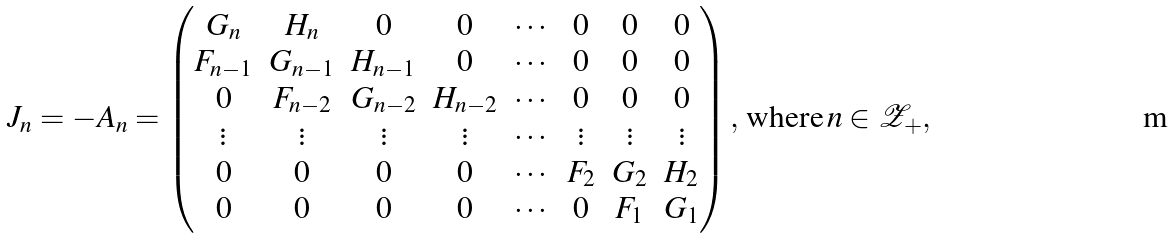Convert formula to latex. <formula><loc_0><loc_0><loc_500><loc_500>J _ { n } = - A _ { n } = \begin{pmatrix} G _ { n } & H _ { n } & 0 & 0 & \cdots & 0 & 0 & 0 \\ F _ { n - 1 } & G _ { n - 1 } & H _ { n - 1 } & 0 & \cdots & 0 & 0 & 0 \\ 0 & F _ { n - 2 } & G _ { n - 2 } & H _ { n - 2 } & \cdots & 0 & 0 & 0 \\ \vdots & \vdots & \vdots & \vdots & \cdots & \vdots & \vdots & \vdots \\ 0 & 0 & 0 & 0 & \cdots & F _ { 2 } & G _ { 2 } & H _ { 2 } \\ 0 & 0 & 0 & 0 & \cdots & 0 & F _ { 1 } & G _ { 1 } \end{pmatrix} , \, \text {where} \, n \in { \mathcal { Z } } _ { + } ,</formula> 